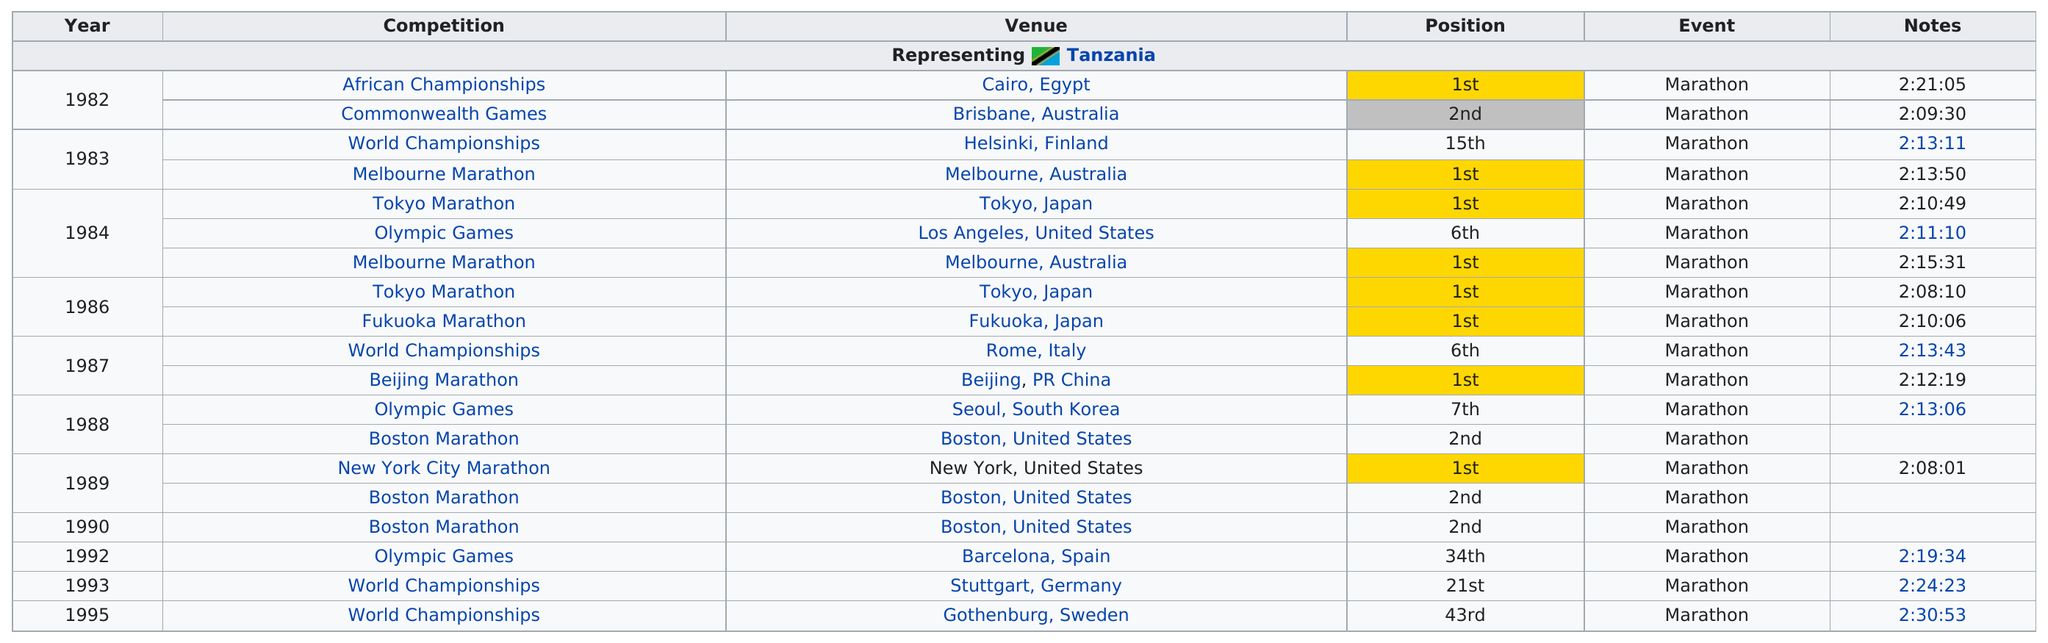Give some essential details in this illustration. In 1984, three competitions were held. The first marathon that Juma Ikangaa won was the 1982 African Championships. The World Championships are the competition that is listed the most in this chart. In the Olympic Games, Ikangaa ran the marathon a total of three times. In the year 1984, the runner participated in the most marathons. 